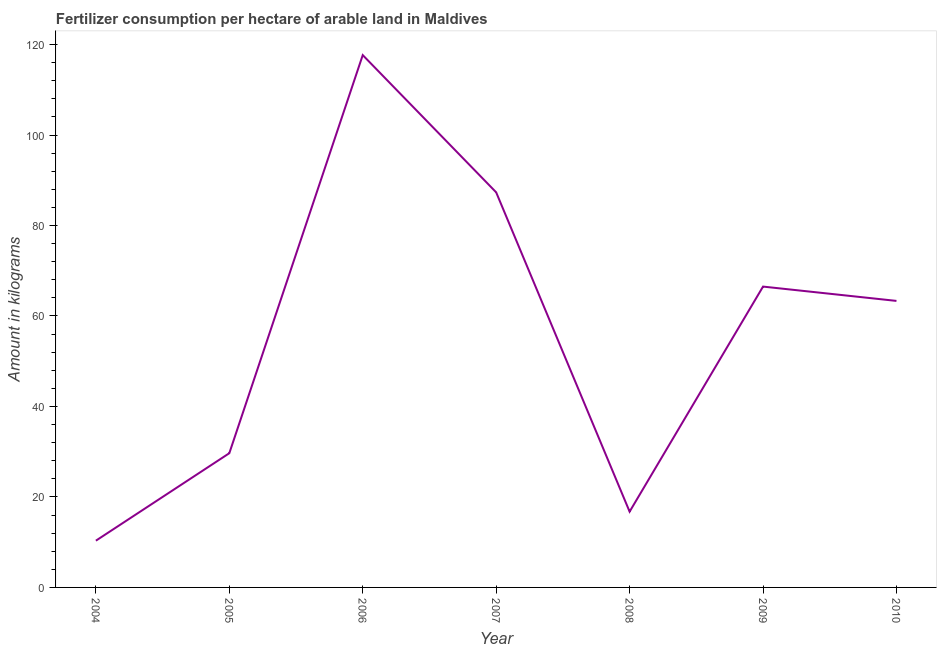What is the amount of fertilizer consumption in 2005?
Your response must be concise. 29.67. Across all years, what is the maximum amount of fertilizer consumption?
Give a very brief answer. 117.67. Across all years, what is the minimum amount of fertilizer consumption?
Make the answer very short. 10.33. In which year was the amount of fertilizer consumption maximum?
Your answer should be compact. 2006. In which year was the amount of fertilizer consumption minimum?
Your answer should be compact. 2004. What is the sum of the amount of fertilizer consumption?
Make the answer very short. 391.58. What is the difference between the amount of fertilizer consumption in 2007 and 2009?
Your response must be concise. 20.83. What is the average amount of fertilizer consumption per year?
Provide a succinct answer. 55.94. What is the median amount of fertilizer consumption?
Provide a succinct answer. 63.33. Do a majority of the years between 2005 and 2007 (inclusive) have amount of fertilizer consumption greater than 48 kg?
Make the answer very short. Yes. What is the ratio of the amount of fertilizer consumption in 2004 to that in 2006?
Make the answer very short. 0.09. Is the amount of fertilizer consumption in 2004 less than that in 2006?
Keep it short and to the point. Yes. What is the difference between the highest and the second highest amount of fertilizer consumption?
Make the answer very short. 30.33. Is the sum of the amount of fertilizer consumption in 2005 and 2008 greater than the maximum amount of fertilizer consumption across all years?
Your answer should be compact. No. What is the difference between the highest and the lowest amount of fertilizer consumption?
Offer a terse response. 107.33. In how many years, is the amount of fertilizer consumption greater than the average amount of fertilizer consumption taken over all years?
Keep it short and to the point. 4. Does the amount of fertilizer consumption monotonically increase over the years?
Provide a short and direct response. No. Are the values on the major ticks of Y-axis written in scientific E-notation?
Give a very brief answer. No. What is the title of the graph?
Your answer should be very brief. Fertilizer consumption per hectare of arable land in Maldives . What is the label or title of the X-axis?
Give a very brief answer. Year. What is the label or title of the Y-axis?
Your answer should be very brief. Amount in kilograms. What is the Amount in kilograms in 2004?
Your answer should be compact. 10.33. What is the Amount in kilograms of 2005?
Give a very brief answer. 29.67. What is the Amount in kilograms in 2006?
Offer a very short reply. 117.67. What is the Amount in kilograms in 2007?
Provide a succinct answer. 87.33. What is the Amount in kilograms of 2008?
Your answer should be compact. 16.75. What is the Amount in kilograms of 2009?
Ensure brevity in your answer.  66.5. What is the Amount in kilograms of 2010?
Your answer should be very brief. 63.33. What is the difference between the Amount in kilograms in 2004 and 2005?
Give a very brief answer. -19.33. What is the difference between the Amount in kilograms in 2004 and 2006?
Make the answer very short. -107.33. What is the difference between the Amount in kilograms in 2004 and 2007?
Offer a terse response. -77. What is the difference between the Amount in kilograms in 2004 and 2008?
Give a very brief answer. -6.42. What is the difference between the Amount in kilograms in 2004 and 2009?
Keep it short and to the point. -56.17. What is the difference between the Amount in kilograms in 2004 and 2010?
Give a very brief answer. -53. What is the difference between the Amount in kilograms in 2005 and 2006?
Your answer should be compact. -88. What is the difference between the Amount in kilograms in 2005 and 2007?
Your answer should be compact. -57.67. What is the difference between the Amount in kilograms in 2005 and 2008?
Ensure brevity in your answer.  12.92. What is the difference between the Amount in kilograms in 2005 and 2009?
Your answer should be compact. -36.83. What is the difference between the Amount in kilograms in 2005 and 2010?
Your answer should be compact. -33.67. What is the difference between the Amount in kilograms in 2006 and 2007?
Keep it short and to the point. 30.33. What is the difference between the Amount in kilograms in 2006 and 2008?
Give a very brief answer. 100.92. What is the difference between the Amount in kilograms in 2006 and 2009?
Your answer should be very brief. 51.17. What is the difference between the Amount in kilograms in 2006 and 2010?
Provide a short and direct response. 54.33. What is the difference between the Amount in kilograms in 2007 and 2008?
Make the answer very short. 70.58. What is the difference between the Amount in kilograms in 2007 and 2009?
Your response must be concise. 20.83. What is the difference between the Amount in kilograms in 2008 and 2009?
Offer a terse response. -49.75. What is the difference between the Amount in kilograms in 2008 and 2010?
Offer a very short reply. -46.58. What is the difference between the Amount in kilograms in 2009 and 2010?
Offer a very short reply. 3.17. What is the ratio of the Amount in kilograms in 2004 to that in 2005?
Keep it short and to the point. 0.35. What is the ratio of the Amount in kilograms in 2004 to that in 2006?
Ensure brevity in your answer.  0.09. What is the ratio of the Amount in kilograms in 2004 to that in 2007?
Ensure brevity in your answer.  0.12. What is the ratio of the Amount in kilograms in 2004 to that in 2008?
Offer a very short reply. 0.62. What is the ratio of the Amount in kilograms in 2004 to that in 2009?
Your response must be concise. 0.15. What is the ratio of the Amount in kilograms in 2004 to that in 2010?
Your answer should be very brief. 0.16. What is the ratio of the Amount in kilograms in 2005 to that in 2006?
Give a very brief answer. 0.25. What is the ratio of the Amount in kilograms in 2005 to that in 2007?
Keep it short and to the point. 0.34. What is the ratio of the Amount in kilograms in 2005 to that in 2008?
Your response must be concise. 1.77. What is the ratio of the Amount in kilograms in 2005 to that in 2009?
Your answer should be very brief. 0.45. What is the ratio of the Amount in kilograms in 2005 to that in 2010?
Provide a succinct answer. 0.47. What is the ratio of the Amount in kilograms in 2006 to that in 2007?
Offer a very short reply. 1.35. What is the ratio of the Amount in kilograms in 2006 to that in 2008?
Ensure brevity in your answer.  7.03. What is the ratio of the Amount in kilograms in 2006 to that in 2009?
Your answer should be compact. 1.77. What is the ratio of the Amount in kilograms in 2006 to that in 2010?
Give a very brief answer. 1.86. What is the ratio of the Amount in kilograms in 2007 to that in 2008?
Give a very brief answer. 5.21. What is the ratio of the Amount in kilograms in 2007 to that in 2009?
Provide a short and direct response. 1.31. What is the ratio of the Amount in kilograms in 2007 to that in 2010?
Provide a short and direct response. 1.38. What is the ratio of the Amount in kilograms in 2008 to that in 2009?
Your response must be concise. 0.25. What is the ratio of the Amount in kilograms in 2008 to that in 2010?
Your response must be concise. 0.26. What is the ratio of the Amount in kilograms in 2009 to that in 2010?
Your answer should be compact. 1.05. 